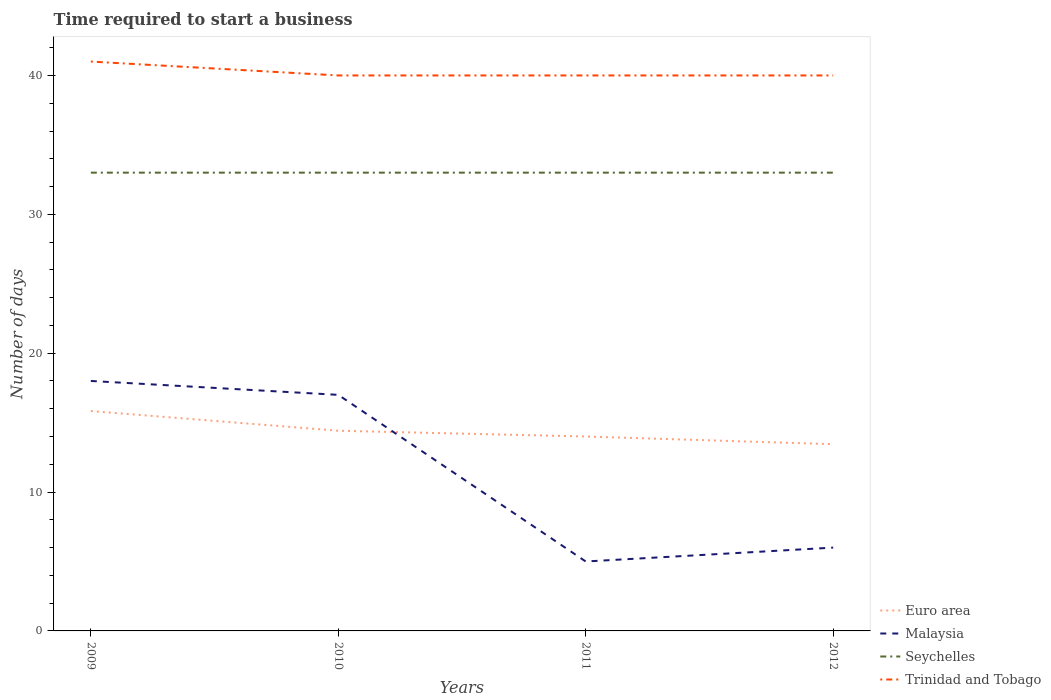How many different coloured lines are there?
Give a very brief answer. 4. Does the line corresponding to Trinidad and Tobago intersect with the line corresponding to Seychelles?
Make the answer very short. No. Is the number of lines equal to the number of legend labels?
Your answer should be very brief. Yes. Across all years, what is the maximum number of days required to start a business in Malaysia?
Provide a succinct answer. 5. In which year was the number of days required to start a business in Trinidad and Tobago maximum?
Provide a short and direct response. 2010. What is the total number of days required to start a business in Euro area in the graph?
Offer a terse response. 0.42. What is the difference between the highest and the second highest number of days required to start a business in Euro area?
Ensure brevity in your answer.  2.39. What is the difference between the highest and the lowest number of days required to start a business in Seychelles?
Give a very brief answer. 0. Is the number of days required to start a business in Euro area strictly greater than the number of days required to start a business in Trinidad and Tobago over the years?
Provide a succinct answer. Yes. How many years are there in the graph?
Your answer should be very brief. 4. Does the graph contain grids?
Ensure brevity in your answer.  No. Where does the legend appear in the graph?
Make the answer very short. Bottom right. How many legend labels are there?
Offer a very short reply. 4. What is the title of the graph?
Make the answer very short. Time required to start a business. What is the label or title of the X-axis?
Offer a terse response. Years. What is the label or title of the Y-axis?
Provide a short and direct response. Number of days. What is the Number of days in Euro area in 2009?
Provide a succinct answer. 15.83. What is the Number of days of Malaysia in 2009?
Provide a succinct answer. 18. What is the Number of days in Trinidad and Tobago in 2009?
Ensure brevity in your answer.  41. What is the Number of days of Euro area in 2010?
Give a very brief answer. 14.42. What is the Number of days in Malaysia in 2010?
Your response must be concise. 17. What is the Number of days of Seychelles in 2010?
Give a very brief answer. 33. What is the Number of days of Trinidad and Tobago in 2010?
Ensure brevity in your answer.  40. What is the Number of days in Malaysia in 2011?
Your answer should be very brief. 5. What is the Number of days in Trinidad and Tobago in 2011?
Your answer should be compact. 40. What is the Number of days of Euro area in 2012?
Ensure brevity in your answer.  13.45. What is the Number of days in Malaysia in 2012?
Provide a succinct answer. 6. What is the Number of days of Seychelles in 2012?
Make the answer very short. 33. Across all years, what is the maximum Number of days of Euro area?
Give a very brief answer. 15.83. Across all years, what is the maximum Number of days in Malaysia?
Make the answer very short. 18. Across all years, what is the maximum Number of days of Seychelles?
Your response must be concise. 33. Across all years, what is the minimum Number of days in Euro area?
Your answer should be compact. 13.45. Across all years, what is the minimum Number of days in Trinidad and Tobago?
Keep it short and to the point. 40. What is the total Number of days in Euro area in the graph?
Give a very brief answer. 57.7. What is the total Number of days in Malaysia in the graph?
Offer a terse response. 46. What is the total Number of days of Seychelles in the graph?
Provide a succinct answer. 132. What is the total Number of days of Trinidad and Tobago in the graph?
Give a very brief answer. 161. What is the difference between the Number of days of Euro area in 2009 and that in 2010?
Make the answer very short. 1.42. What is the difference between the Number of days in Trinidad and Tobago in 2009 and that in 2010?
Give a very brief answer. 1. What is the difference between the Number of days of Euro area in 2009 and that in 2011?
Provide a short and direct response. 1.83. What is the difference between the Number of days of Malaysia in 2009 and that in 2011?
Your response must be concise. 13. What is the difference between the Number of days of Euro area in 2009 and that in 2012?
Give a very brief answer. 2.39. What is the difference between the Number of days in Euro area in 2010 and that in 2011?
Offer a terse response. 0.42. What is the difference between the Number of days of Seychelles in 2010 and that in 2011?
Give a very brief answer. 0. What is the difference between the Number of days in Euro area in 2010 and that in 2012?
Offer a terse response. 0.97. What is the difference between the Number of days in Seychelles in 2010 and that in 2012?
Provide a short and direct response. 0. What is the difference between the Number of days of Trinidad and Tobago in 2010 and that in 2012?
Provide a short and direct response. 0. What is the difference between the Number of days of Euro area in 2011 and that in 2012?
Your answer should be compact. 0.55. What is the difference between the Number of days of Seychelles in 2011 and that in 2012?
Offer a terse response. 0. What is the difference between the Number of days in Trinidad and Tobago in 2011 and that in 2012?
Your answer should be very brief. 0. What is the difference between the Number of days of Euro area in 2009 and the Number of days of Malaysia in 2010?
Ensure brevity in your answer.  -1.17. What is the difference between the Number of days of Euro area in 2009 and the Number of days of Seychelles in 2010?
Provide a short and direct response. -17.17. What is the difference between the Number of days in Euro area in 2009 and the Number of days in Trinidad and Tobago in 2010?
Make the answer very short. -24.17. What is the difference between the Number of days of Malaysia in 2009 and the Number of days of Seychelles in 2010?
Make the answer very short. -15. What is the difference between the Number of days in Malaysia in 2009 and the Number of days in Trinidad and Tobago in 2010?
Your answer should be very brief. -22. What is the difference between the Number of days in Seychelles in 2009 and the Number of days in Trinidad and Tobago in 2010?
Your response must be concise. -7. What is the difference between the Number of days of Euro area in 2009 and the Number of days of Malaysia in 2011?
Provide a short and direct response. 10.83. What is the difference between the Number of days of Euro area in 2009 and the Number of days of Seychelles in 2011?
Your response must be concise. -17.17. What is the difference between the Number of days of Euro area in 2009 and the Number of days of Trinidad and Tobago in 2011?
Keep it short and to the point. -24.17. What is the difference between the Number of days in Seychelles in 2009 and the Number of days in Trinidad and Tobago in 2011?
Provide a short and direct response. -7. What is the difference between the Number of days in Euro area in 2009 and the Number of days in Malaysia in 2012?
Make the answer very short. 9.83. What is the difference between the Number of days in Euro area in 2009 and the Number of days in Seychelles in 2012?
Offer a terse response. -17.17. What is the difference between the Number of days in Euro area in 2009 and the Number of days in Trinidad and Tobago in 2012?
Ensure brevity in your answer.  -24.17. What is the difference between the Number of days of Malaysia in 2009 and the Number of days of Trinidad and Tobago in 2012?
Provide a succinct answer. -22. What is the difference between the Number of days in Seychelles in 2009 and the Number of days in Trinidad and Tobago in 2012?
Provide a short and direct response. -7. What is the difference between the Number of days of Euro area in 2010 and the Number of days of Malaysia in 2011?
Your answer should be very brief. 9.42. What is the difference between the Number of days in Euro area in 2010 and the Number of days in Seychelles in 2011?
Give a very brief answer. -18.58. What is the difference between the Number of days of Euro area in 2010 and the Number of days of Trinidad and Tobago in 2011?
Offer a terse response. -25.58. What is the difference between the Number of days in Seychelles in 2010 and the Number of days in Trinidad and Tobago in 2011?
Offer a terse response. -7. What is the difference between the Number of days of Euro area in 2010 and the Number of days of Malaysia in 2012?
Offer a terse response. 8.42. What is the difference between the Number of days of Euro area in 2010 and the Number of days of Seychelles in 2012?
Ensure brevity in your answer.  -18.58. What is the difference between the Number of days of Euro area in 2010 and the Number of days of Trinidad and Tobago in 2012?
Provide a succinct answer. -25.58. What is the difference between the Number of days in Malaysia in 2010 and the Number of days in Seychelles in 2012?
Give a very brief answer. -16. What is the difference between the Number of days in Malaysia in 2010 and the Number of days in Trinidad and Tobago in 2012?
Give a very brief answer. -23. What is the difference between the Number of days of Seychelles in 2010 and the Number of days of Trinidad and Tobago in 2012?
Your answer should be very brief. -7. What is the difference between the Number of days in Malaysia in 2011 and the Number of days in Seychelles in 2012?
Make the answer very short. -28. What is the difference between the Number of days of Malaysia in 2011 and the Number of days of Trinidad and Tobago in 2012?
Make the answer very short. -35. What is the difference between the Number of days of Seychelles in 2011 and the Number of days of Trinidad and Tobago in 2012?
Offer a very short reply. -7. What is the average Number of days of Euro area per year?
Keep it short and to the point. 14.42. What is the average Number of days in Malaysia per year?
Offer a terse response. 11.5. What is the average Number of days in Trinidad and Tobago per year?
Your answer should be very brief. 40.25. In the year 2009, what is the difference between the Number of days of Euro area and Number of days of Malaysia?
Offer a very short reply. -2.17. In the year 2009, what is the difference between the Number of days in Euro area and Number of days in Seychelles?
Your response must be concise. -17.17. In the year 2009, what is the difference between the Number of days in Euro area and Number of days in Trinidad and Tobago?
Offer a very short reply. -25.17. In the year 2009, what is the difference between the Number of days in Seychelles and Number of days in Trinidad and Tobago?
Your answer should be compact. -8. In the year 2010, what is the difference between the Number of days of Euro area and Number of days of Malaysia?
Provide a short and direct response. -2.58. In the year 2010, what is the difference between the Number of days in Euro area and Number of days in Seychelles?
Give a very brief answer. -18.58. In the year 2010, what is the difference between the Number of days of Euro area and Number of days of Trinidad and Tobago?
Your answer should be compact. -25.58. In the year 2010, what is the difference between the Number of days in Malaysia and Number of days in Seychelles?
Your answer should be very brief. -16. In the year 2010, what is the difference between the Number of days in Malaysia and Number of days in Trinidad and Tobago?
Give a very brief answer. -23. In the year 2011, what is the difference between the Number of days of Euro area and Number of days of Malaysia?
Your answer should be compact. 9. In the year 2011, what is the difference between the Number of days of Euro area and Number of days of Seychelles?
Ensure brevity in your answer.  -19. In the year 2011, what is the difference between the Number of days in Malaysia and Number of days in Seychelles?
Make the answer very short. -28. In the year 2011, what is the difference between the Number of days in Malaysia and Number of days in Trinidad and Tobago?
Offer a very short reply. -35. In the year 2011, what is the difference between the Number of days in Seychelles and Number of days in Trinidad and Tobago?
Your answer should be compact. -7. In the year 2012, what is the difference between the Number of days of Euro area and Number of days of Malaysia?
Your answer should be very brief. 7.45. In the year 2012, what is the difference between the Number of days of Euro area and Number of days of Seychelles?
Offer a very short reply. -19.55. In the year 2012, what is the difference between the Number of days in Euro area and Number of days in Trinidad and Tobago?
Offer a terse response. -26.55. In the year 2012, what is the difference between the Number of days in Malaysia and Number of days in Trinidad and Tobago?
Ensure brevity in your answer.  -34. What is the ratio of the Number of days of Euro area in 2009 to that in 2010?
Ensure brevity in your answer.  1.1. What is the ratio of the Number of days of Malaysia in 2009 to that in 2010?
Your response must be concise. 1.06. What is the ratio of the Number of days in Seychelles in 2009 to that in 2010?
Provide a short and direct response. 1. What is the ratio of the Number of days in Trinidad and Tobago in 2009 to that in 2010?
Offer a very short reply. 1.02. What is the ratio of the Number of days in Euro area in 2009 to that in 2011?
Your response must be concise. 1.13. What is the ratio of the Number of days of Trinidad and Tobago in 2009 to that in 2011?
Make the answer very short. 1.02. What is the ratio of the Number of days in Euro area in 2009 to that in 2012?
Your answer should be very brief. 1.18. What is the ratio of the Number of days in Seychelles in 2009 to that in 2012?
Provide a succinct answer. 1. What is the ratio of the Number of days of Euro area in 2010 to that in 2011?
Your answer should be compact. 1.03. What is the ratio of the Number of days of Trinidad and Tobago in 2010 to that in 2011?
Offer a very short reply. 1. What is the ratio of the Number of days in Euro area in 2010 to that in 2012?
Ensure brevity in your answer.  1.07. What is the ratio of the Number of days of Malaysia in 2010 to that in 2012?
Offer a very short reply. 2.83. What is the ratio of the Number of days of Seychelles in 2010 to that in 2012?
Offer a very short reply. 1. What is the ratio of the Number of days of Trinidad and Tobago in 2010 to that in 2012?
Offer a very short reply. 1. What is the ratio of the Number of days of Euro area in 2011 to that in 2012?
Ensure brevity in your answer.  1.04. What is the ratio of the Number of days of Seychelles in 2011 to that in 2012?
Offer a terse response. 1. What is the ratio of the Number of days of Trinidad and Tobago in 2011 to that in 2012?
Ensure brevity in your answer.  1. What is the difference between the highest and the second highest Number of days in Euro area?
Ensure brevity in your answer.  1.42. What is the difference between the highest and the second highest Number of days of Malaysia?
Offer a terse response. 1. What is the difference between the highest and the second highest Number of days in Seychelles?
Give a very brief answer. 0. What is the difference between the highest and the second highest Number of days of Trinidad and Tobago?
Your answer should be very brief. 1. What is the difference between the highest and the lowest Number of days of Euro area?
Your answer should be compact. 2.39. What is the difference between the highest and the lowest Number of days of Malaysia?
Provide a short and direct response. 13. What is the difference between the highest and the lowest Number of days in Trinidad and Tobago?
Your answer should be very brief. 1. 